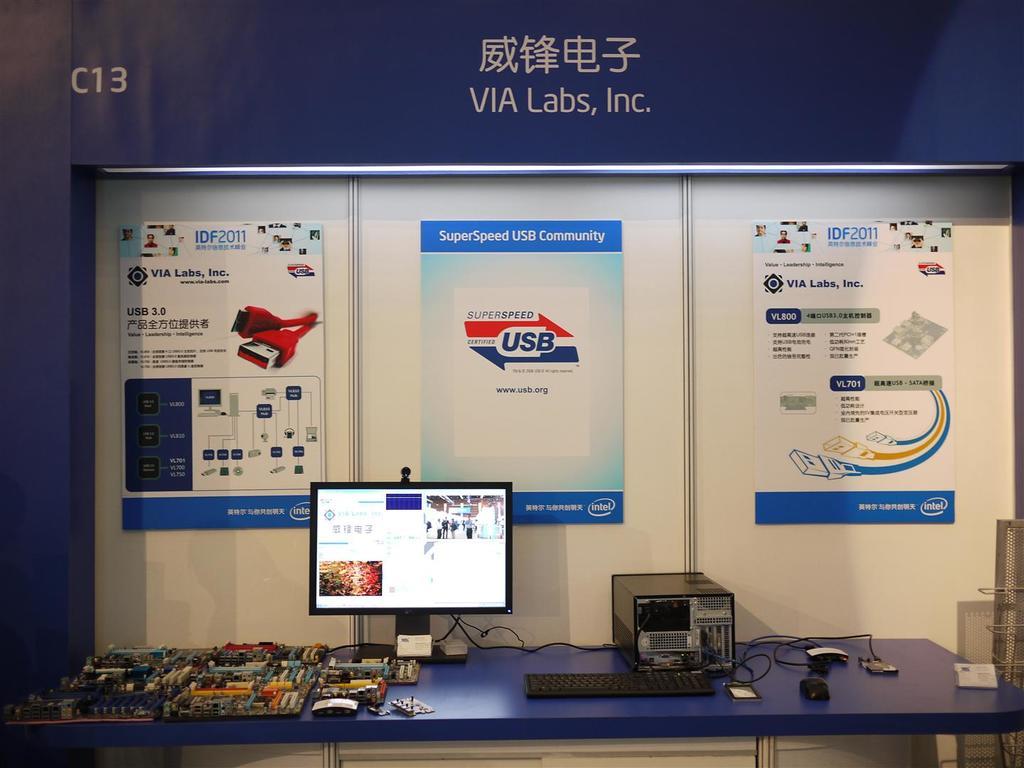What company is assigned to that booth?
Make the answer very short. Via labs. What type of community is this according to the display?
Make the answer very short. Super speed usb. 